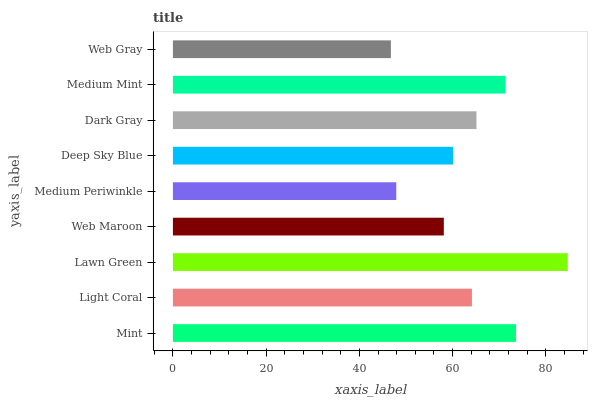Is Web Gray the minimum?
Answer yes or no. Yes. Is Lawn Green the maximum?
Answer yes or no. Yes. Is Light Coral the minimum?
Answer yes or no. No. Is Light Coral the maximum?
Answer yes or no. No. Is Mint greater than Light Coral?
Answer yes or no. Yes. Is Light Coral less than Mint?
Answer yes or no. Yes. Is Light Coral greater than Mint?
Answer yes or no. No. Is Mint less than Light Coral?
Answer yes or no. No. Is Light Coral the high median?
Answer yes or no. Yes. Is Light Coral the low median?
Answer yes or no. Yes. Is Web Gray the high median?
Answer yes or no. No. Is Dark Gray the low median?
Answer yes or no. No. 